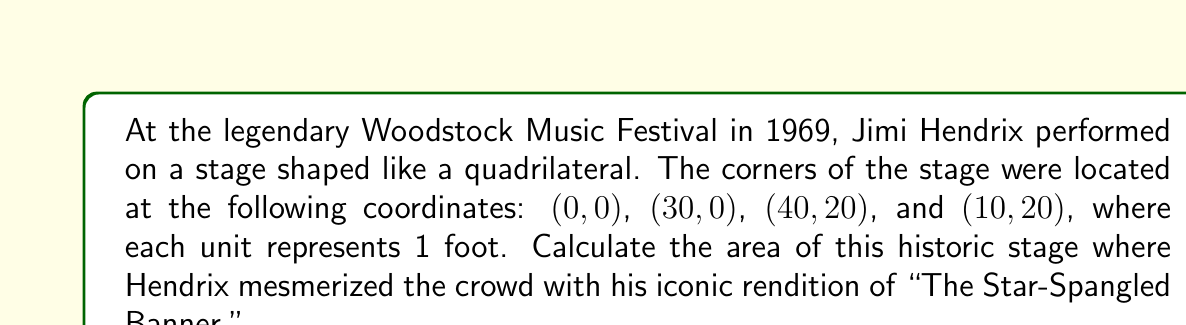Could you help me with this problem? To find the area of the quadrilateral stage, we can use the Shoelace formula (also known as the surveyor's formula). This method calculates the area of a polygon given the coordinates of its vertices.

The formula is:

$$ A = \frac{1}{2}|\sum_{i=1}^{n} (x_i y_{i+1} - x_{i+1} y_i)| $$

Where $(x_i, y_i)$ are the coordinates of the $i$-th vertex, and $(x_{n+1}, y_{n+1}) = (x_1, y_1)$.

Let's apply this to our coordinates:

1) List the coordinates in order:
   $(x_1, y_1) = (0, 0)$
   $(x_2, y_2) = (30, 0)$
   $(x_3, y_3) = (40, 20)$
   $(x_4, y_4) = (10, 20)$

2) Calculate each term in the sum:
   $0 \cdot 0 - 30 \cdot 0 = 0$
   $30 \cdot 20 - 40 \cdot 0 = 600$
   $40 \cdot 20 - 10 \cdot 20 = 600$
   $10 \cdot 0 - 0 \cdot 20 = 0$

3) Sum these terms:
   $0 + 600 + 600 + 0 = 1200$

4) Take the absolute value and divide by 2:
   $A = \frac{1}{2}|1200| = 600$

Therefore, the area of the stage is 600 square feet.

[asy]
unitsize(4pt);
draw((0,0)--(30,0)--(40,20)--(10,20)--cycle);
label("(0,0)", (0,0), SW);
label("(30,0)", (30,0), SE);
label("(40,20)", (40,20), NE);
label("(10,20)", (10,20), NW);
[/asy]
Answer: 600 sq ft 